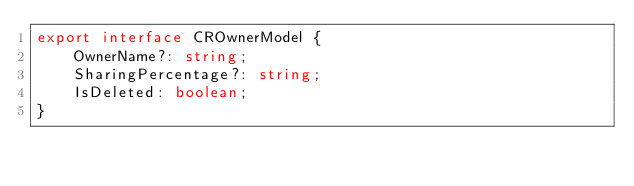Convert code to text. <code><loc_0><loc_0><loc_500><loc_500><_TypeScript_>export interface CROwnerModel {
    OwnerName?: string;
    SharingPercentage?: string;
    IsDeleted: boolean;
}
</code> 